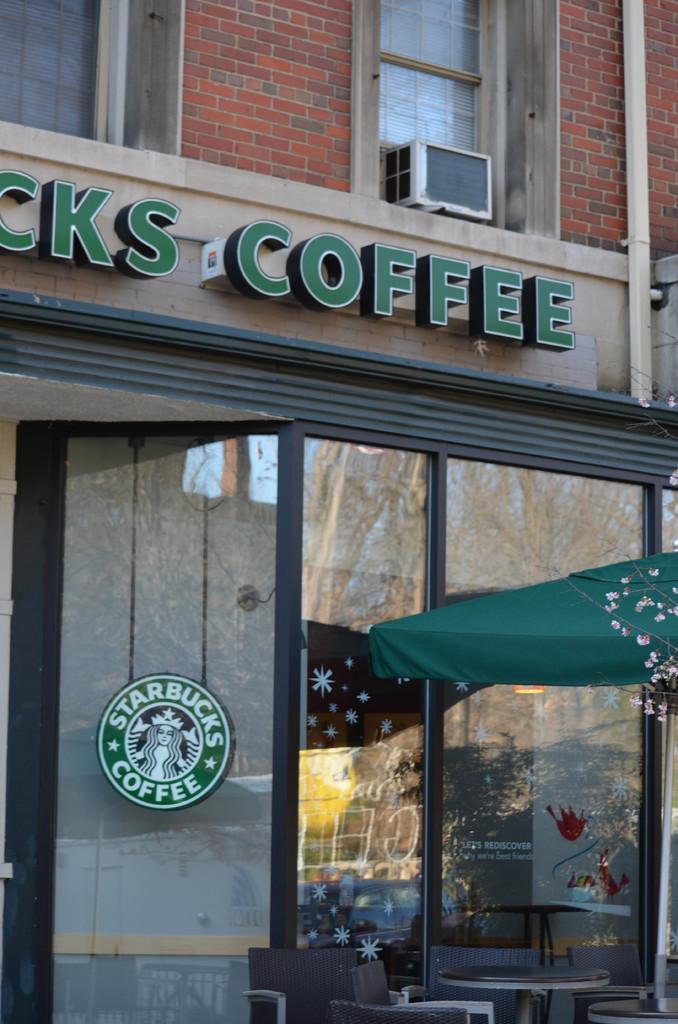In one or two sentences, can you explain what this image depicts? In this image, we can see part of a building. There is a tent on the right side of the image. There is a table and some chairs in the bottom right of the image. 